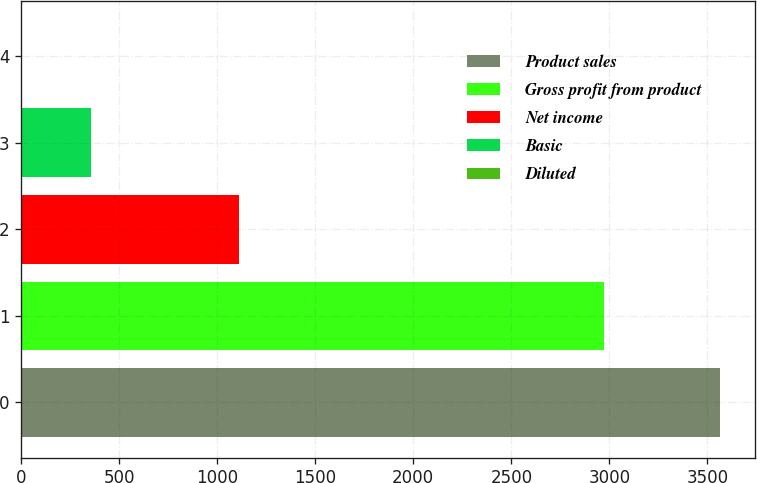Convert chart to OTSL. <chart><loc_0><loc_0><loc_500><loc_500><bar_chart><fcel>Product sales<fcel>Gross profit from product<fcel>Net income<fcel>Basic<fcel>Diluted<nl><fcel>3565<fcel>2973<fcel>1111<fcel>357.35<fcel>0.94<nl></chart> 